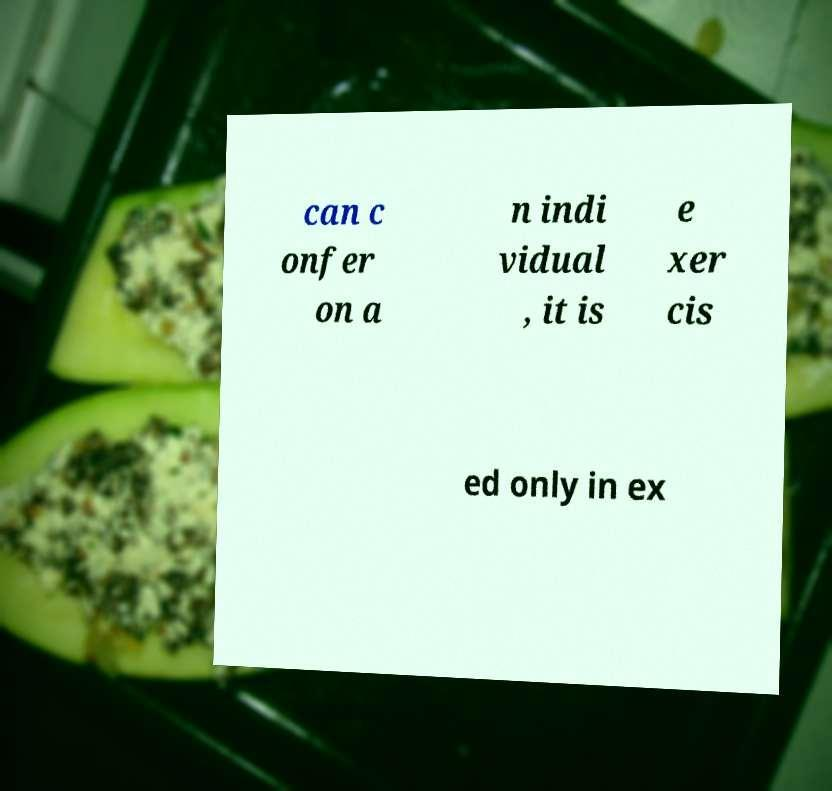I need the written content from this picture converted into text. Can you do that? can c onfer on a n indi vidual , it is e xer cis ed only in ex 